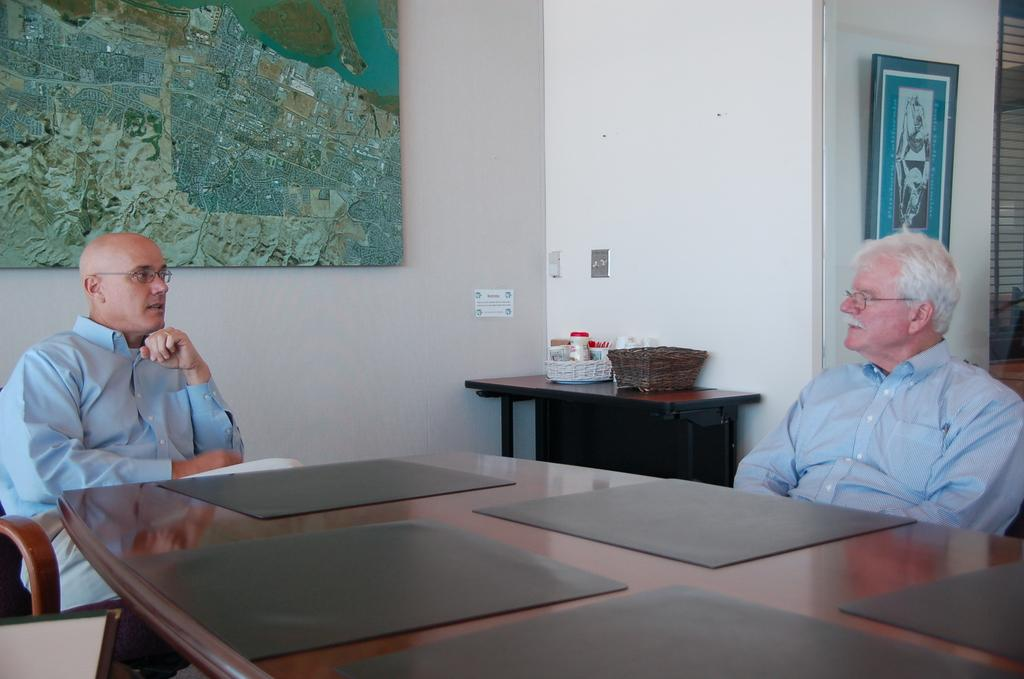How many people are sitting in the image? There are two persons sitting on chairs in the image. What can be seen on the tables in the image? There are table mats and baskets on the tables. What is present on the wall in the background of the image? There are frames attached to the wall in the background of the image. What type of lettuce can be seen growing in the wilderness in the image? There is no lettuce or wilderness present in the image. 